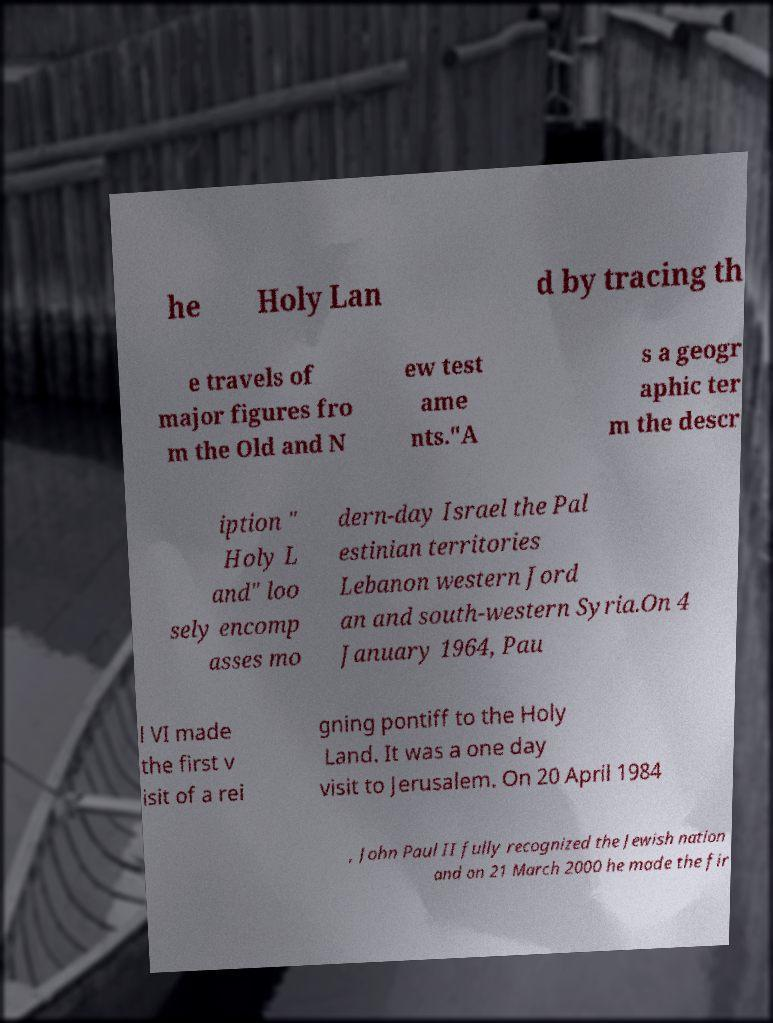Please read and relay the text visible in this image. What does it say? he Holy Lan d by tracing th e travels of major figures fro m the Old and N ew test ame nts."A s a geogr aphic ter m the descr iption " Holy L and" loo sely encomp asses mo dern-day Israel the Pal estinian territories Lebanon western Jord an and south-western Syria.On 4 January 1964, Pau l VI made the first v isit of a rei gning pontiff to the Holy Land. It was a one day visit to Jerusalem. On 20 April 1984 , John Paul II fully recognized the Jewish nation and on 21 March 2000 he made the fir 